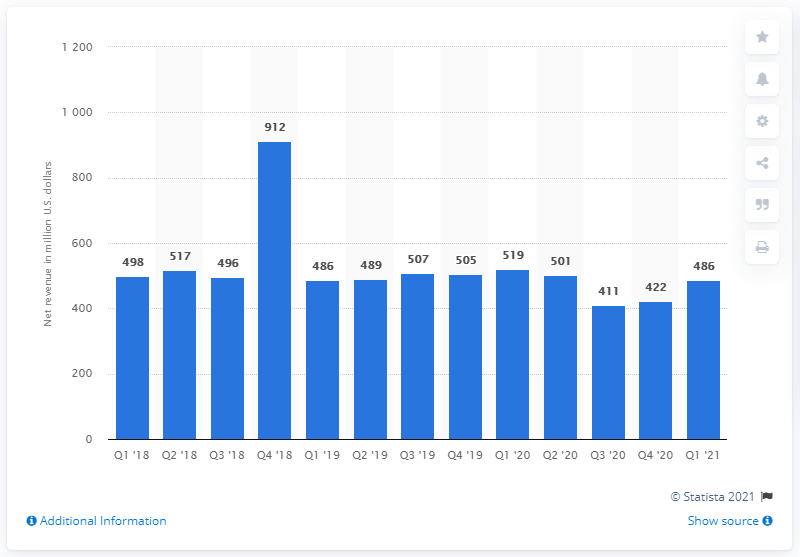Draw attention to some important aspects in this diagram. Intel's PSG revenue in the first quarter of 2021 was $486 million. In the fourth quarter of 2020, the company's revenue was 422.. 